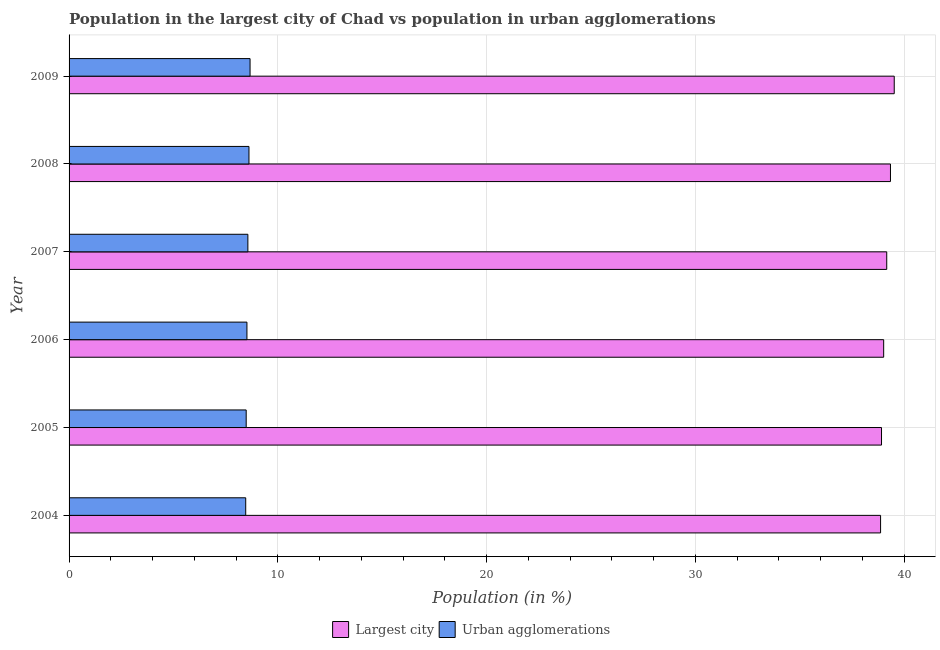How many different coloured bars are there?
Provide a succinct answer. 2. Are the number of bars per tick equal to the number of legend labels?
Provide a succinct answer. Yes. How many bars are there on the 6th tick from the top?
Keep it short and to the point. 2. What is the label of the 6th group of bars from the top?
Make the answer very short. 2004. In how many cases, is the number of bars for a given year not equal to the number of legend labels?
Your answer should be very brief. 0. What is the population in urban agglomerations in 2004?
Offer a terse response. 8.46. Across all years, what is the maximum population in urban agglomerations?
Make the answer very short. 8.67. Across all years, what is the minimum population in the largest city?
Give a very brief answer. 38.87. In which year was the population in the largest city maximum?
Keep it short and to the point. 2009. In which year was the population in the largest city minimum?
Keep it short and to the point. 2004. What is the total population in urban agglomerations in the graph?
Ensure brevity in your answer.  51.32. What is the difference between the population in urban agglomerations in 2006 and that in 2008?
Your response must be concise. -0.1. What is the difference between the population in the largest city in 2008 and the population in urban agglomerations in 2007?
Offer a very short reply. 30.78. What is the average population in the largest city per year?
Provide a succinct answer. 39.14. In the year 2007, what is the difference between the population in urban agglomerations and population in the largest city?
Provide a short and direct response. -30.6. In how many years, is the population in the largest city greater than 12 %?
Make the answer very short. 6. Is the population in urban agglomerations in 2004 less than that in 2007?
Your answer should be compact. Yes. What is the difference between the highest and the second highest population in the largest city?
Your answer should be compact. 0.18. What is the difference between the highest and the lowest population in urban agglomerations?
Make the answer very short. 0.21. In how many years, is the population in urban agglomerations greater than the average population in urban agglomerations taken over all years?
Your answer should be very brief. 3. Is the sum of the population in the largest city in 2006 and 2008 greater than the maximum population in urban agglomerations across all years?
Your answer should be very brief. Yes. What does the 1st bar from the top in 2004 represents?
Provide a short and direct response. Urban agglomerations. What does the 2nd bar from the bottom in 2008 represents?
Offer a very short reply. Urban agglomerations. How many bars are there?
Ensure brevity in your answer.  12. Are all the bars in the graph horizontal?
Your response must be concise. Yes. Are the values on the major ticks of X-axis written in scientific E-notation?
Provide a short and direct response. No. Where does the legend appear in the graph?
Your answer should be compact. Bottom center. How many legend labels are there?
Make the answer very short. 2. What is the title of the graph?
Keep it short and to the point. Population in the largest city of Chad vs population in urban agglomerations. Does "Female entrants" appear as one of the legend labels in the graph?
Your response must be concise. No. What is the label or title of the Y-axis?
Offer a terse response. Year. What is the Population (in %) of Largest city in 2004?
Make the answer very short. 38.87. What is the Population (in %) of Urban agglomerations in 2004?
Keep it short and to the point. 8.46. What is the Population (in %) in Largest city in 2005?
Keep it short and to the point. 38.92. What is the Population (in %) in Urban agglomerations in 2005?
Make the answer very short. 8.48. What is the Population (in %) of Largest city in 2006?
Your response must be concise. 39.02. What is the Population (in %) in Urban agglomerations in 2006?
Your answer should be compact. 8.52. What is the Population (in %) of Largest city in 2007?
Make the answer very short. 39.17. What is the Population (in %) in Urban agglomerations in 2007?
Your response must be concise. 8.57. What is the Population (in %) in Largest city in 2008?
Make the answer very short. 39.35. What is the Population (in %) in Urban agglomerations in 2008?
Give a very brief answer. 8.62. What is the Population (in %) in Largest city in 2009?
Provide a short and direct response. 39.53. What is the Population (in %) of Urban agglomerations in 2009?
Your answer should be compact. 8.67. Across all years, what is the maximum Population (in %) of Largest city?
Your response must be concise. 39.53. Across all years, what is the maximum Population (in %) in Urban agglomerations?
Ensure brevity in your answer.  8.67. Across all years, what is the minimum Population (in %) of Largest city?
Offer a very short reply. 38.87. Across all years, what is the minimum Population (in %) of Urban agglomerations?
Your answer should be very brief. 8.46. What is the total Population (in %) of Largest city in the graph?
Your response must be concise. 234.85. What is the total Population (in %) in Urban agglomerations in the graph?
Provide a short and direct response. 51.32. What is the difference between the Population (in %) in Largest city in 2004 and that in 2005?
Make the answer very short. -0.05. What is the difference between the Population (in %) in Urban agglomerations in 2004 and that in 2005?
Keep it short and to the point. -0.02. What is the difference between the Population (in %) in Largest city in 2004 and that in 2006?
Your answer should be very brief. -0.15. What is the difference between the Population (in %) in Urban agglomerations in 2004 and that in 2006?
Your response must be concise. -0.06. What is the difference between the Population (in %) in Largest city in 2004 and that in 2007?
Your response must be concise. -0.29. What is the difference between the Population (in %) in Urban agglomerations in 2004 and that in 2007?
Your answer should be very brief. -0.1. What is the difference between the Population (in %) of Largest city in 2004 and that in 2008?
Offer a very short reply. -0.47. What is the difference between the Population (in %) in Urban agglomerations in 2004 and that in 2008?
Make the answer very short. -0.16. What is the difference between the Population (in %) of Largest city in 2004 and that in 2009?
Your answer should be compact. -0.65. What is the difference between the Population (in %) of Urban agglomerations in 2004 and that in 2009?
Keep it short and to the point. -0.21. What is the difference between the Population (in %) of Largest city in 2005 and that in 2006?
Your response must be concise. -0.1. What is the difference between the Population (in %) of Urban agglomerations in 2005 and that in 2006?
Make the answer very short. -0.04. What is the difference between the Population (in %) of Largest city in 2005 and that in 2007?
Your answer should be very brief. -0.25. What is the difference between the Population (in %) of Urban agglomerations in 2005 and that in 2007?
Your response must be concise. -0.08. What is the difference between the Population (in %) in Largest city in 2005 and that in 2008?
Give a very brief answer. -0.43. What is the difference between the Population (in %) of Urban agglomerations in 2005 and that in 2008?
Provide a succinct answer. -0.13. What is the difference between the Population (in %) in Largest city in 2005 and that in 2009?
Give a very brief answer. -0.61. What is the difference between the Population (in %) in Urban agglomerations in 2005 and that in 2009?
Offer a very short reply. -0.19. What is the difference between the Population (in %) of Largest city in 2006 and that in 2007?
Provide a short and direct response. -0.15. What is the difference between the Population (in %) of Urban agglomerations in 2006 and that in 2007?
Ensure brevity in your answer.  -0.05. What is the difference between the Population (in %) of Largest city in 2006 and that in 2008?
Make the answer very short. -0.33. What is the difference between the Population (in %) of Urban agglomerations in 2006 and that in 2008?
Offer a very short reply. -0.1. What is the difference between the Population (in %) in Largest city in 2006 and that in 2009?
Keep it short and to the point. -0.51. What is the difference between the Population (in %) in Largest city in 2007 and that in 2008?
Your answer should be compact. -0.18. What is the difference between the Population (in %) in Urban agglomerations in 2007 and that in 2008?
Ensure brevity in your answer.  -0.05. What is the difference between the Population (in %) of Largest city in 2007 and that in 2009?
Your response must be concise. -0.36. What is the difference between the Population (in %) in Urban agglomerations in 2007 and that in 2009?
Your answer should be very brief. -0.1. What is the difference between the Population (in %) in Largest city in 2008 and that in 2009?
Provide a short and direct response. -0.18. What is the difference between the Population (in %) of Urban agglomerations in 2008 and that in 2009?
Your response must be concise. -0.05. What is the difference between the Population (in %) in Largest city in 2004 and the Population (in %) in Urban agglomerations in 2005?
Make the answer very short. 30.39. What is the difference between the Population (in %) of Largest city in 2004 and the Population (in %) of Urban agglomerations in 2006?
Make the answer very short. 30.35. What is the difference between the Population (in %) of Largest city in 2004 and the Population (in %) of Urban agglomerations in 2007?
Your answer should be compact. 30.31. What is the difference between the Population (in %) of Largest city in 2004 and the Population (in %) of Urban agglomerations in 2008?
Offer a very short reply. 30.26. What is the difference between the Population (in %) in Largest city in 2004 and the Population (in %) in Urban agglomerations in 2009?
Offer a very short reply. 30.2. What is the difference between the Population (in %) in Largest city in 2005 and the Population (in %) in Urban agglomerations in 2006?
Your response must be concise. 30.4. What is the difference between the Population (in %) in Largest city in 2005 and the Population (in %) in Urban agglomerations in 2007?
Provide a succinct answer. 30.35. What is the difference between the Population (in %) in Largest city in 2005 and the Population (in %) in Urban agglomerations in 2008?
Ensure brevity in your answer.  30.3. What is the difference between the Population (in %) in Largest city in 2005 and the Population (in %) in Urban agglomerations in 2009?
Ensure brevity in your answer.  30.25. What is the difference between the Population (in %) in Largest city in 2006 and the Population (in %) in Urban agglomerations in 2007?
Provide a succinct answer. 30.46. What is the difference between the Population (in %) of Largest city in 2006 and the Population (in %) of Urban agglomerations in 2008?
Provide a short and direct response. 30.4. What is the difference between the Population (in %) in Largest city in 2006 and the Population (in %) in Urban agglomerations in 2009?
Give a very brief answer. 30.35. What is the difference between the Population (in %) in Largest city in 2007 and the Population (in %) in Urban agglomerations in 2008?
Your answer should be compact. 30.55. What is the difference between the Population (in %) in Largest city in 2007 and the Population (in %) in Urban agglomerations in 2009?
Your response must be concise. 30.5. What is the difference between the Population (in %) of Largest city in 2008 and the Population (in %) of Urban agglomerations in 2009?
Ensure brevity in your answer.  30.68. What is the average Population (in %) in Largest city per year?
Give a very brief answer. 39.14. What is the average Population (in %) of Urban agglomerations per year?
Your response must be concise. 8.55. In the year 2004, what is the difference between the Population (in %) in Largest city and Population (in %) in Urban agglomerations?
Give a very brief answer. 30.41. In the year 2005, what is the difference between the Population (in %) in Largest city and Population (in %) in Urban agglomerations?
Ensure brevity in your answer.  30.43. In the year 2006, what is the difference between the Population (in %) in Largest city and Population (in %) in Urban agglomerations?
Your answer should be very brief. 30.5. In the year 2007, what is the difference between the Population (in %) of Largest city and Population (in %) of Urban agglomerations?
Keep it short and to the point. 30.6. In the year 2008, what is the difference between the Population (in %) of Largest city and Population (in %) of Urban agglomerations?
Your response must be concise. 30.73. In the year 2009, what is the difference between the Population (in %) in Largest city and Population (in %) in Urban agglomerations?
Your answer should be compact. 30.86. What is the ratio of the Population (in %) of Urban agglomerations in 2004 to that in 2007?
Make the answer very short. 0.99. What is the ratio of the Population (in %) in Largest city in 2004 to that in 2008?
Your response must be concise. 0.99. What is the ratio of the Population (in %) of Urban agglomerations in 2004 to that in 2008?
Offer a terse response. 0.98. What is the ratio of the Population (in %) in Largest city in 2004 to that in 2009?
Provide a succinct answer. 0.98. What is the ratio of the Population (in %) of Urban agglomerations in 2004 to that in 2009?
Offer a terse response. 0.98. What is the ratio of the Population (in %) in Urban agglomerations in 2005 to that in 2007?
Make the answer very short. 0.99. What is the ratio of the Population (in %) in Largest city in 2005 to that in 2008?
Provide a succinct answer. 0.99. What is the ratio of the Population (in %) in Urban agglomerations in 2005 to that in 2008?
Give a very brief answer. 0.98. What is the ratio of the Population (in %) of Largest city in 2005 to that in 2009?
Ensure brevity in your answer.  0.98. What is the ratio of the Population (in %) of Urban agglomerations in 2005 to that in 2009?
Give a very brief answer. 0.98. What is the ratio of the Population (in %) in Urban agglomerations in 2006 to that in 2008?
Your response must be concise. 0.99. What is the ratio of the Population (in %) of Largest city in 2006 to that in 2009?
Your answer should be compact. 0.99. What is the ratio of the Population (in %) in Urban agglomerations in 2006 to that in 2009?
Give a very brief answer. 0.98. What is the ratio of the Population (in %) of Largest city in 2007 to that in 2009?
Offer a very short reply. 0.99. What is the ratio of the Population (in %) in Urban agglomerations in 2007 to that in 2009?
Make the answer very short. 0.99. What is the ratio of the Population (in %) of Largest city in 2008 to that in 2009?
Give a very brief answer. 1. What is the difference between the highest and the second highest Population (in %) of Largest city?
Offer a terse response. 0.18. What is the difference between the highest and the second highest Population (in %) in Urban agglomerations?
Your answer should be very brief. 0.05. What is the difference between the highest and the lowest Population (in %) of Largest city?
Provide a short and direct response. 0.65. What is the difference between the highest and the lowest Population (in %) in Urban agglomerations?
Your answer should be compact. 0.21. 